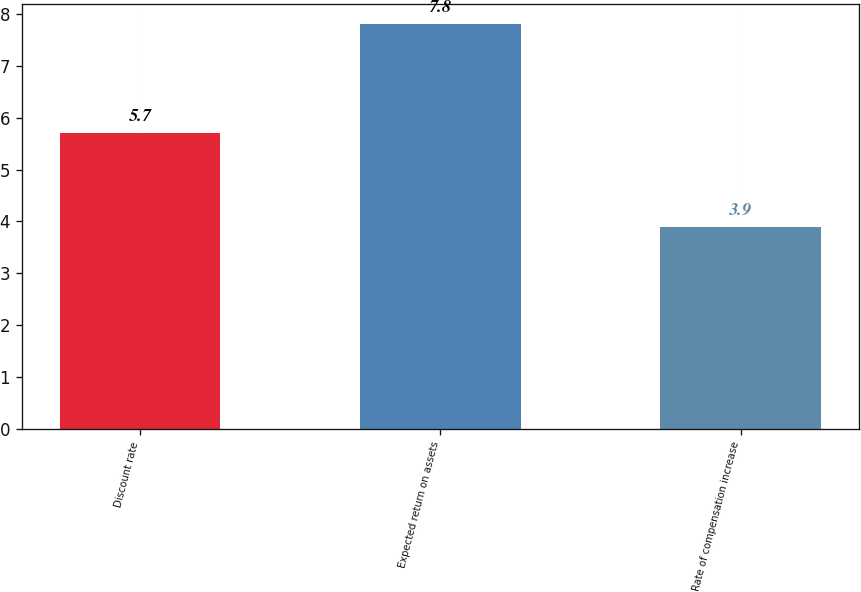<chart> <loc_0><loc_0><loc_500><loc_500><bar_chart><fcel>Discount rate<fcel>Expected return on assets<fcel>Rate of compensation increase<nl><fcel>5.7<fcel>7.8<fcel>3.9<nl></chart> 